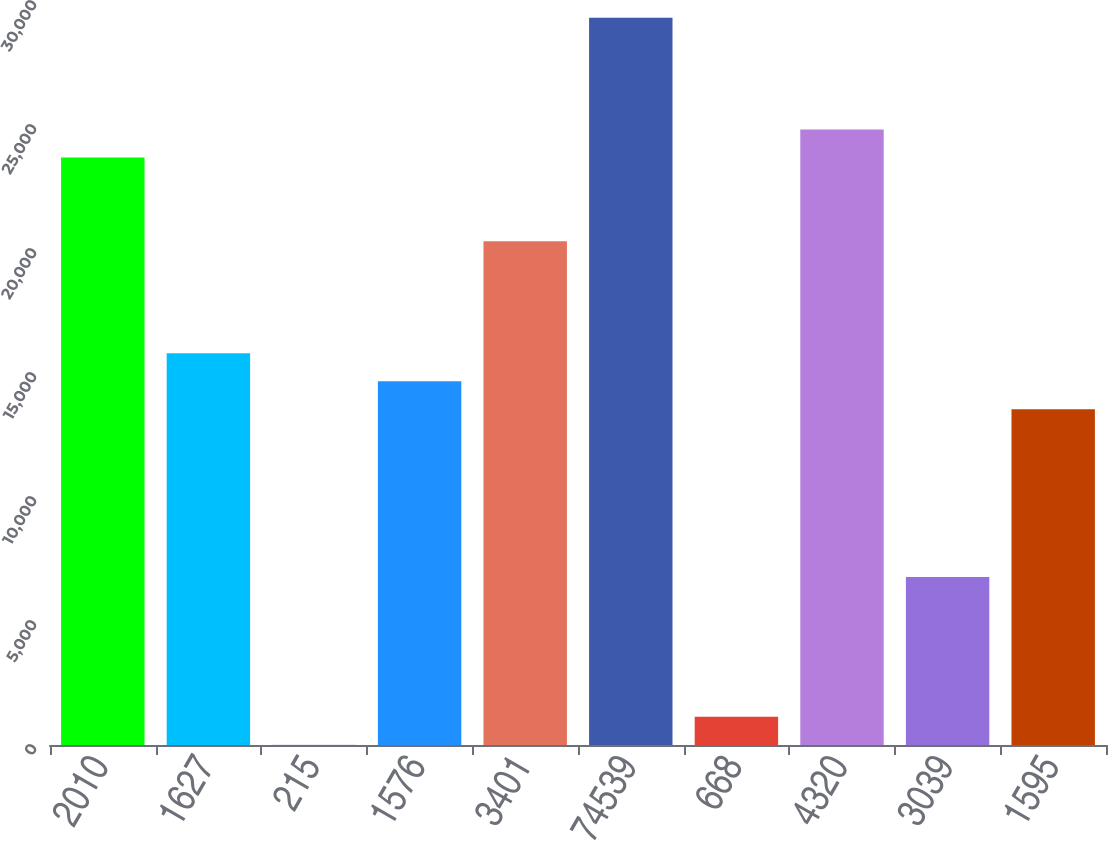Convert chart. <chart><loc_0><loc_0><loc_500><loc_500><bar_chart><fcel>2010<fcel>1627<fcel>215<fcel>1576<fcel>3401<fcel>74539<fcel>668<fcel>4320<fcel>3039<fcel>1595<nl><fcel>23690.8<fcel>15797.5<fcel>10.82<fcel>14669.9<fcel>20308<fcel>29328.9<fcel>1138.44<fcel>24818.5<fcel>6776.54<fcel>13542.3<nl></chart> 